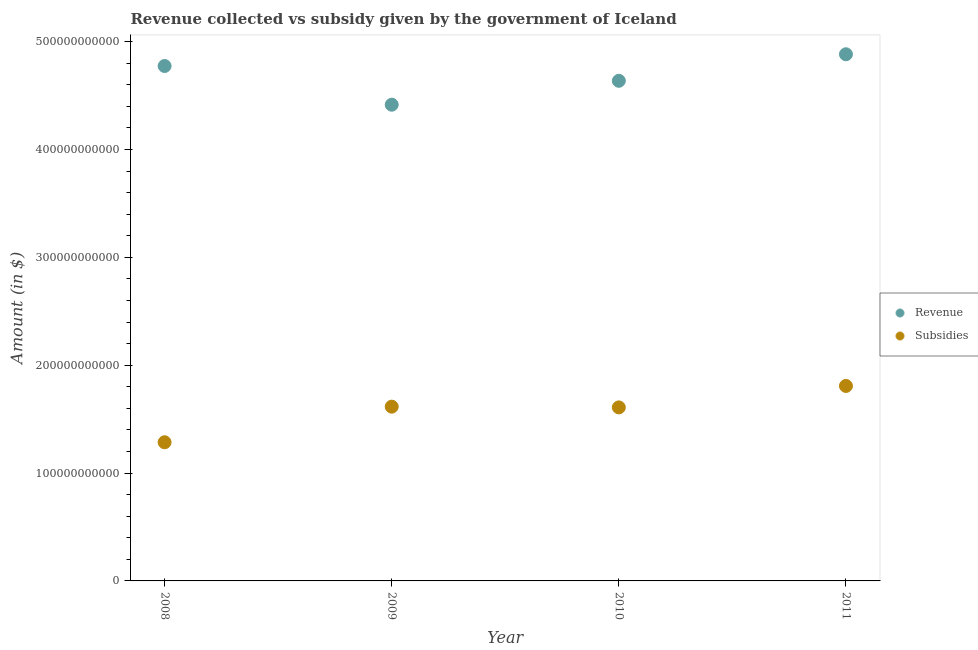Is the number of dotlines equal to the number of legend labels?
Your response must be concise. Yes. What is the amount of revenue collected in 2009?
Ensure brevity in your answer.  4.42e+11. Across all years, what is the maximum amount of subsidies given?
Your answer should be compact. 1.81e+11. Across all years, what is the minimum amount of revenue collected?
Your answer should be compact. 4.42e+11. What is the total amount of subsidies given in the graph?
Provide a succinct answer. 6.32e+11. What is the difference between the amount of revenue collected in 2010 and that in 2011?
Keep it short and to the point. -2.46e+1. What is the difference between the amount of subsidies given in 2011 and the amount of revenue collected in 2010?
Provide a succinct answer. -2.83e+11. What is the average amount of revenue collected per year?
Provide a short and direct response. 4.68e+11. In the year 2011, what is the difference between the amount of revenue collected and amount of subsidies given?
Provide a short and direct response. 3.08e+11. What is the ratio of the amount of subsidies given in 2008 to that in 2010?
Provide a short and direct response. 0.8. Is the amount of subsidies given in 2010 less than that in 2011?
Ensure brevity in your answer.  Yes. Is the difference between the amount of revenue collected in 2010 and 2011 greater than the difference between the amount of subsidies given in 2010 and 2011?
Make the answer very short. No. What is the difference between the highest and the second highest amount of revenue collected?
Your answer should be compact. 1.09e+1. What is the difference between the highest and the lowest amount of revenue collected?
Keep it short and to the point. 4.68e+1. In how many years, is the amount of subsidies given greater than the average amount of subsidies given taken over all years?
Your answer should be very brief. 3. Is the amount of subsidies given strictly greater than the amount of revenue collected over the years?
Make the answer very short. No. Is the amount of subsidies given strictly less than the amount of revenue collected over the years?
Ensure brevity in your answer.  Yes. How many years are there in the graph?
Make the answer very short. 4. What is the difference between two consecutive major ticks on the Y-axis?
Provide a succinct answer. 1.00e+11. Are the values on the major ticks of Y-axis written in scientific E-notation?
Your answer should be very brief. No. Does the graph contain any zero values?
Your response must be concise. No. Does the graph contain grids?
Provide a short and direct response. No. Where does the legend appear in the graph?
Your response must be concise. Center right. How are the legend labels stacked?
Keep it short and to the point. Vertical. What is the title of the graph?
Ensure brevity in your answer.  Revenue collected vs subsidy given by the government of Iceland. Does "Merchandise imports" appear as one of the legend labels in the graph?
Offer a terse response. No. What is the label or title of the Y-axis?
Provide a succinct answer. Amount (in $). What is the Amount (in $) of Revenue in 2008?
Your response must be concise. 4.77e+11. What is the Amount (in $) in Subsidies in 2008?
Ensure brevity in your answer.  1.29e+11. What is the Amount (in $) in Revenue in 2009?
Your response must be concise. 4.42e+11. What is the Amount (in $) of Subsidies in 2009?
Offer a terse response. 1.62e+11. What is the Amount (in $) of Revenue in 2010?
Keep it short and to the point. 4.64e+11. What is the Amount (in $) in Subsidies in 2010?
Ensure brevity in your answer.  1.61e+11. What is the Amount (in $) of Revenue in 2011?
Make the answer very short. 4.88e+11. What is the Amount (in $) in Subsidies in 2011?
Offer a very short reply. 1.81e+11. Across all years, what is the maximum Amount (in $) of Revenue?
Your answer should be very brief. 4.88e+11. Across all years, what is the maximum Amount (in $) in Subsidies?
Make the answer very short. 1.81e+11. Across all years, what is the minimum Amount (in $) in Revenue?
Give a very brief answer. 4.42e+11. Across all years, what is the minimum Amount (in $) in Subsidies?
Give a very brief answer. 1.29e+11. What is the total Amount (in $) of Revenue in the graph?
Ensure brevity in your answer.  1.87e+12. What is the total Amount (in $) of Subsidies in the graph?
Give a very brief answer. 6.32e+11. What is the difference between the Amount (in $) in Revenue in 2008 and that in 2009?
Ensure brevity in your answer.  3.59e+1. What is the difference between the Amount (in $) in Subsidies in 2008 and that in 2009?
Give a very brief answer. -3.30e+1. What is the difference between the Amount (in $) in Revenue in 2008 and that in 2010?
Give a very brief answer. 1.37e+1. What is the difference between the Amount (in $) in Subsidies in 2008 and that in 2010?
Offer a very short reply. -3.23e+1. What is the difference between the Amount (in $) of Revenue in 2008 and that in 2011?
Your answer should be very brief. -1.09e+1. What is the difference between the Amount (in $) in Subsidies in 2008 and that in 2011?
Provide a short and direct response. -5.22e+1. What is the difference between the Amount (in $) of Revenue in 2009 and that in 2010?
Make the answer very short. -2.22e+1. What is the difference between the Amount (in $) of Subsidies in 2009 and that in 2010?
Ensure brevity in your answer.  6.76e+08. What is the difference between the Amount (in $) of Revenue in 2009 and that in 2011?
Provide a succinct answer. -4.68e+1. What is the difference between the Amount (in $) of Subsidies in 2009 and that in 2011?
Give a very brief answer. -1.92e+1. What is the difference between the Amount (in $) of Revenue in 2010 and that in 2011?
Your answer should be compact. -2.46e+1. What is the difference between the Amount (in $) in Subsidies in 2010 and that in 2011?
Ensure brevity in your answer.  -1.99e+1. What is the difference between the Amount (in $) of Revenue in 2008 and the Amount (in $) of Subsidies in 2009?
Give a very brief answer. 3.16e+11. What is the difference between the Amount (in $) in Revenue in 2008 and the Amount (in $) in Subsidies in 2010?
Make the answer very short. 3.17e+11. What is the difference between the Amount (in $) in Revenue in 2008 and the Amount (in $) in Subsidies in 2011?
Make the answer very short. 2.97e+11. What is the difference between the Amount (in $) in Revenue in 2009 and the Amount (in $) in Subsidies in 2010?
Your answer should be very brief. 2.81e+11. What is the difference between the Amount (in $) in Revenue in 2009 and the Amount (in $) in Subsidies in 2011?
Your response must be concise. 2.61e+11. What is the difference between the Amount (in $) of Revenue in 2010 and the Amount (in $) of Subsidies in 2011?
Give a very brief answer. 2.83e+11. What is the average Amount (in $) in Revenue per year?
Your response must be concise. 4.68e+11. What is the average Amount (in $) of Subsidies per year?
Your response must be concise. 1.58e+11. In the year 2008, what is the difference between the Amount (in $) of Revenue and Amount (in $) of Subsidies?
Keep it short and to the point. 3.49e+11. In the year 2009, what is the difference between the Amount (in $) of Revenue and Amount (in $) of Subsidies?
Make the answer very short. 2.80e+11. In the year 2010, what is the difference between the Amount (in $) in Revenue and Amount (in $) in Subsidies?
Your answer should be very brief. 3.03e+11. In the year 2011, what is the difference between the Amount (in $) in Revenue and Amount (in $) in Subsidies?
Your response must be concise. 3.08e+11. What is the ratio of the Amount (in $) in Revenue in 2008 to that in 2009?
Make the answer very short. 1.08. What is the ratio of the Amount (in $) in Subsidies in 2008 to that in 2009?
Provide a succinct answer. 0.8. What is the ratio of the Amount (in $) of Revenue in 2008 to that in 2010?
Offer a very short reply. 1.03. What is the ratio of the Amount (in $) of Subsidies in 2008 to that in 2010?
Your answer should be very brief. 0.8. What is the ratio of the Amount (in $) of Revenue in 2008 to that in 2011?
Offer a very short reply. 0.98. What is the ratio of the Amount (in $) in Subsidies in 2008 to that in 2011?
Give a very brief answer. 0.71. What is the ratio of the Amount (in $) in Revenue in 2009 to that in 2010?
Offer a very short reply. 0.95. What is the ratio of the Amount (in $) in Revenue in 2009 to that in 2011?
Give a very brief answer. 0.9. What is the ratio of the Amount (in $) in Subsidies in 2009 to that in 2011?
Keep it short and to the point. 0.89. What is the ratio of the Amount (in $) in Revenue in 2010 to that in 2011?
Make the answer very short. 0.95. What is the ratio of the Amount (in $) of Subsidies in 2010 to that in 2011?
Your response must be concise. 0.89. What is the difference between the highest and the second highest Amount (in $) in Revenue?
Give a very brief answer. 1.09e+1. What is the difference between the highest and the second highest Amount (in $) in Subsidies?
Make the answer very short. 1.92e+1. What is the difference between the highest and the lowest Amount (in $) in Revenue?
Give a very brief answer. 4.68e+1. What is the difference between the highest and the lowest Amount (in $) in Subsidies?
Provide a short and direct response. 5.22e+1. 